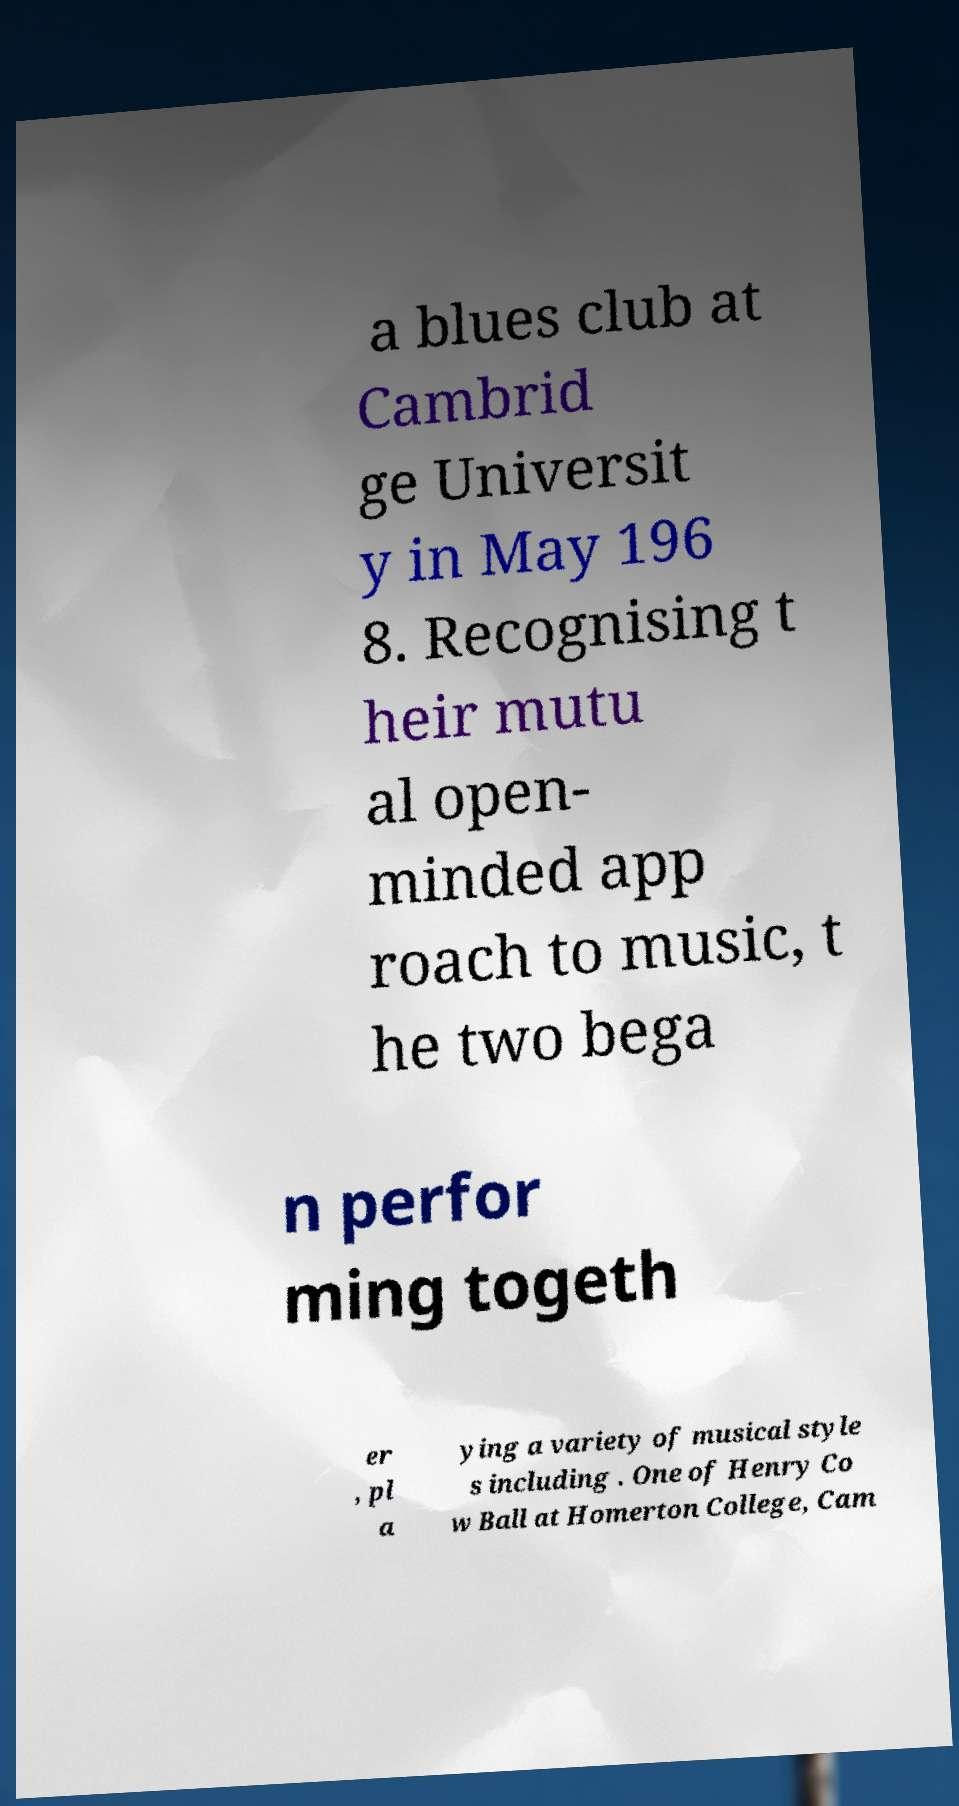Please identify and transcribe the text found in this image. a blues club at Cambrid ge Universit y in May 196 8. Recognising t heir mutu al open- minded app roach to music, t he two bega n perfor ming togeth er , pl a ying a variety of musical style s including . One of Henry Co w Ball at Homerton College, Cam 